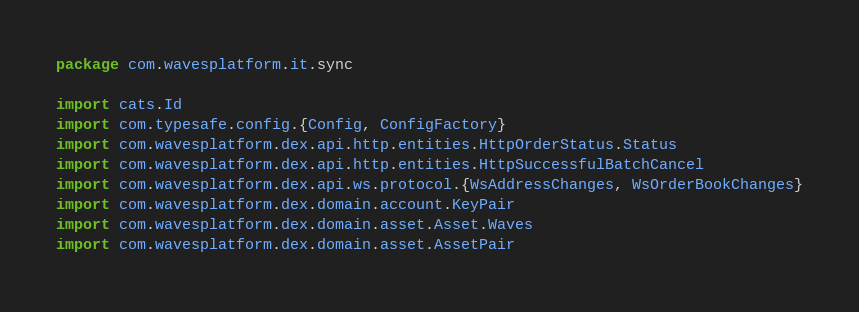<code> <loc_0><loc_0><loc_500><loc_500><_Scala_>package com.wavesplatform.it.sync

import cats.Id
import com.typesafe.config.{Config, ConfigFactory}
import com.wavesplatform.dex.api.http.entities.HttpOrderStatus.Status
import com.wavesplatform.dex.api.http.entities.HttpSuccessfulBatchCancel
import com.wavesplatform.dex.api.ws.protocol.{WsAddressChanges, WsOrderBookChanges}
import com.wavesplatform.dex.domain.account.KeyPair
import com.wavesplatform.dex.domain.asset.Asset.Waves
import com.wavesplatform.dex.domain.asset.AssetPair</code> 